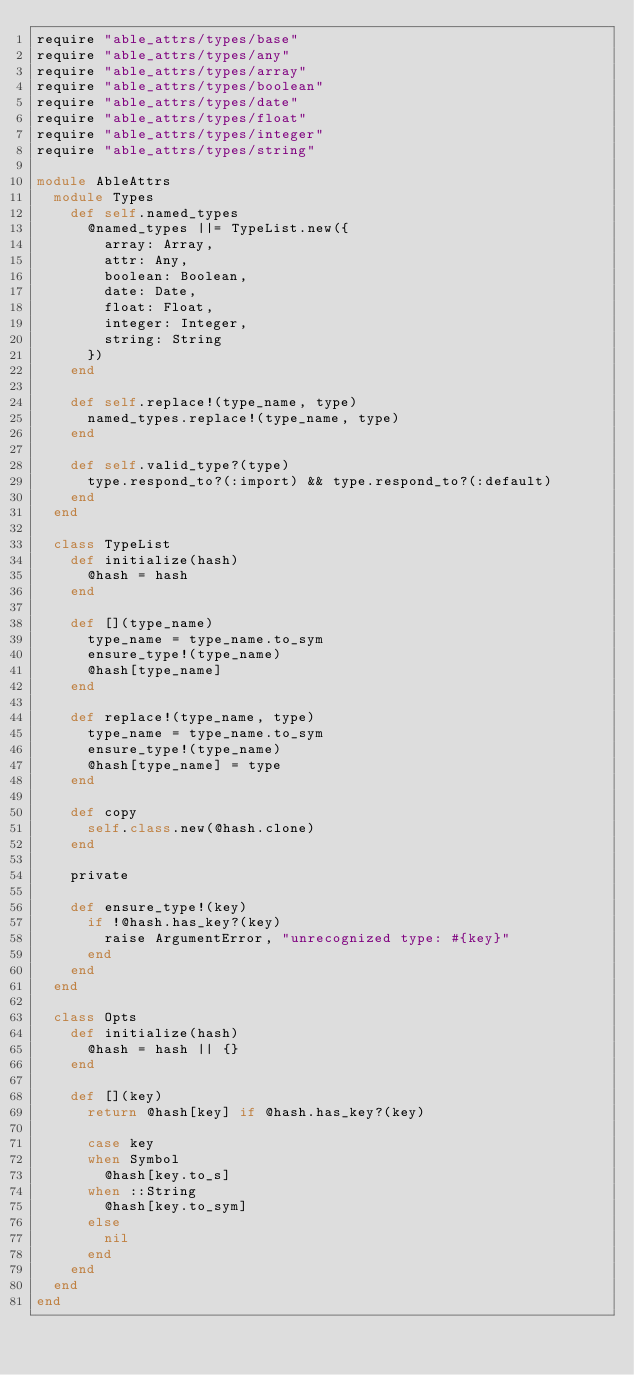<code> <loc_0><loc_0><loc_500><loc_500><_Ruby_>require "able_attrs/types/base"
require "able_attrs/types/any"
require "able_attrs/types/array"
require "able_attrs/types/boolean"
require "able_attrs/types/date"
require "able_attrs/types/float"
require "able_attrs/types/integer"
require "able_attrs/types/string"

module AbleAttrs
  module Types
    def self.named_types
      @named_types ||= TypeList.new({
        array: Array,
        attr: Any,
        boolean: Boolean,
        date: Date,
        float: Float,
        integer: Integer,
        string: String
      })
    end

    def self.replace!(type_name, type)
      named_types.replace!(type_name, type)
    end

    def self.valid_type?(type)
      type.respond_to?(:import) && type.respond_to?(:default)
    end
  end

  class TypeList
    def initialize(hash)
      @hash = hash
    end

    def [](type_name)
      type_name = type_name.to_sym
      ensure_type!(type_name)
      @hash[type_name]
    end

    def replace!(type_name, type)
      type_name = type_name.to_sym
      ensure_type!(type_name)
      @hash[type_name] = type
    end

    def copy
      self.class.new(@hash.clone)
    end

    private

    def ensure_type!(key)
      if !@hash.has_key?(key)
        raise ArgumentError, "unrecognized type: #{key}"
      end
    end
  end

  class Opts
    def initialize(hash)
      @hash = hash || {}
    end

    def [](key)
      return @hash[key] if @hash.has_key?(key)

      case key
      when Symbol
        @hash[key.to_s]
      when ::String
        @hash[key.to_sym]
      else
        nil
      end
    end
  end
end

</code> 